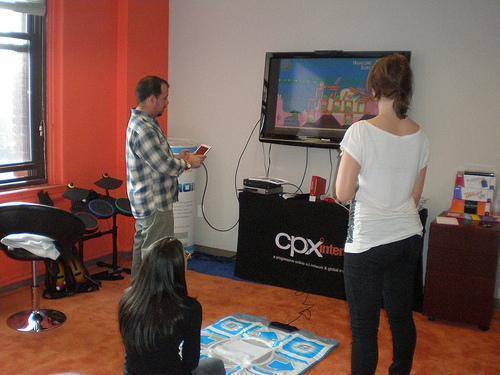How many people in picture?
Give a very brief answer. 3. How many people are reading book?
Give a very brief answer. 0. How many people are sitting on the floor?
Give a very brief answer. 1. 